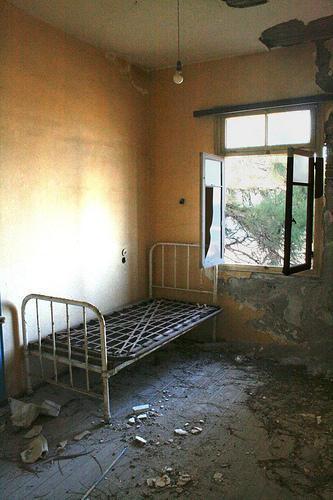How many windows are open?
Give a very brief answer. 1. 